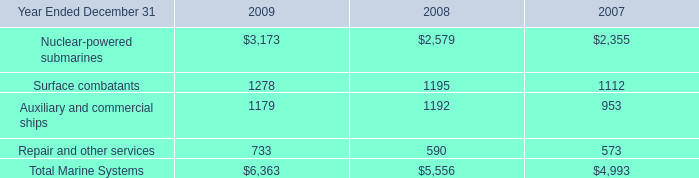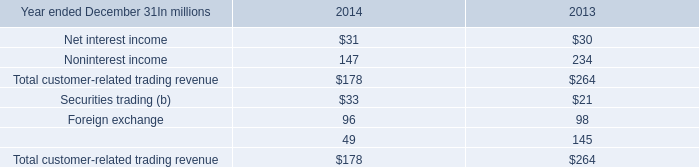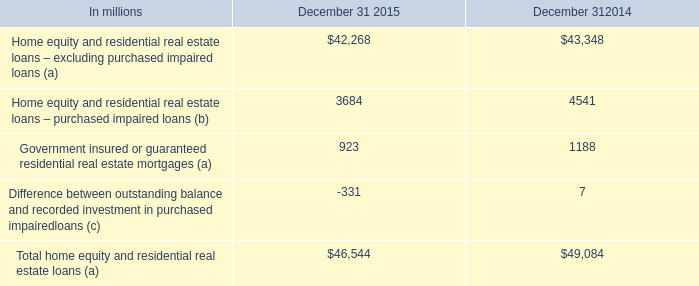What is the growing rate of Total home equity and residential real estate loans (a) in the years with the least Total home equity and residential real estate loans (a)? 
Computations: ((46544 - 49084) / 46544)
Answer: -0.05457. 